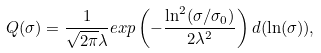Convert formula to latex. <formula><loc_0><loc_0><loc_500><loc_500>Q ( \sigma ) = \frac { 1 } { \sqrt { 2 \pi } \lambda } e x p \left ( - \frac { \ln ^ { 2 } ( \sigma / \sigma _ { 0 } ) } { 2 \lambda ^ { 2 } } \right ) d ( \ln ( \sigma ) ) ,</formula> 